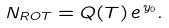<formula> <loc_0><loc_0><loc_500><loc_500>N _ { R O T } = Q ( T ) \, e ^ { \, y _ { 0 } } .</formula> 